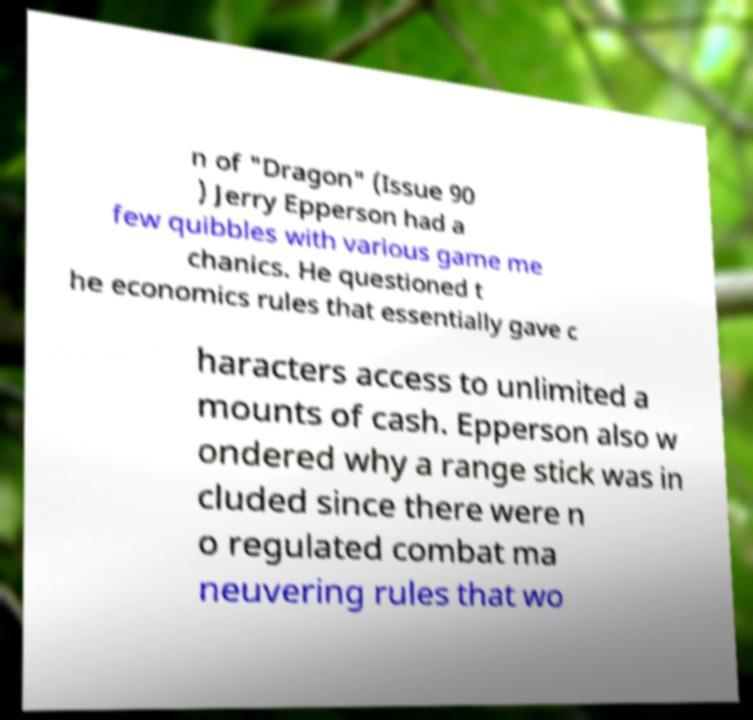Could you extract and type out the text from this image? n of "Dragon" (Issue 90 ) Jerry Epperson had a few quibbles with various game me chanics. He questioned t he economics rules that essentially gave c haracters access to unlimited a mounts of cash. Epperson also w ondered why a range stick was in cluded since there were n o regulated combat ma neuvering rules that wo 